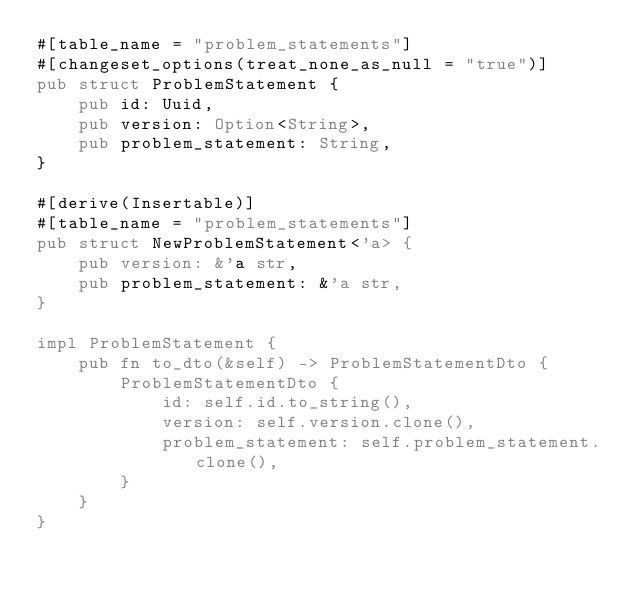<code> <loc_0><loc_0><loc_500><loc_500><_Rust_>#[table_name = "problem_statements"]
#[changeset_options(treat_none_as_null = "true")]
pub struct ProblemStatement {
    pub id: Uuid,
    pub version: Option<String>,
    pub problem_statement: String,
}

#[derive(Insertable)]
#[table_name = "problem_statements"]
pub struct NewProblemStatement<'a> {
    pub version: &'a str,
    pub problem_statement: &'a str,
}

impl ProblemStatement {
    pub fn to_dto(&self) -> ProblemStatementDto {
        ProblemStatementDto {
            id: self.id.to_string(),
            version: self.version.clone(),
            problem_statement: self.problem_statement.clone(),
        }
    }
}
</code> 